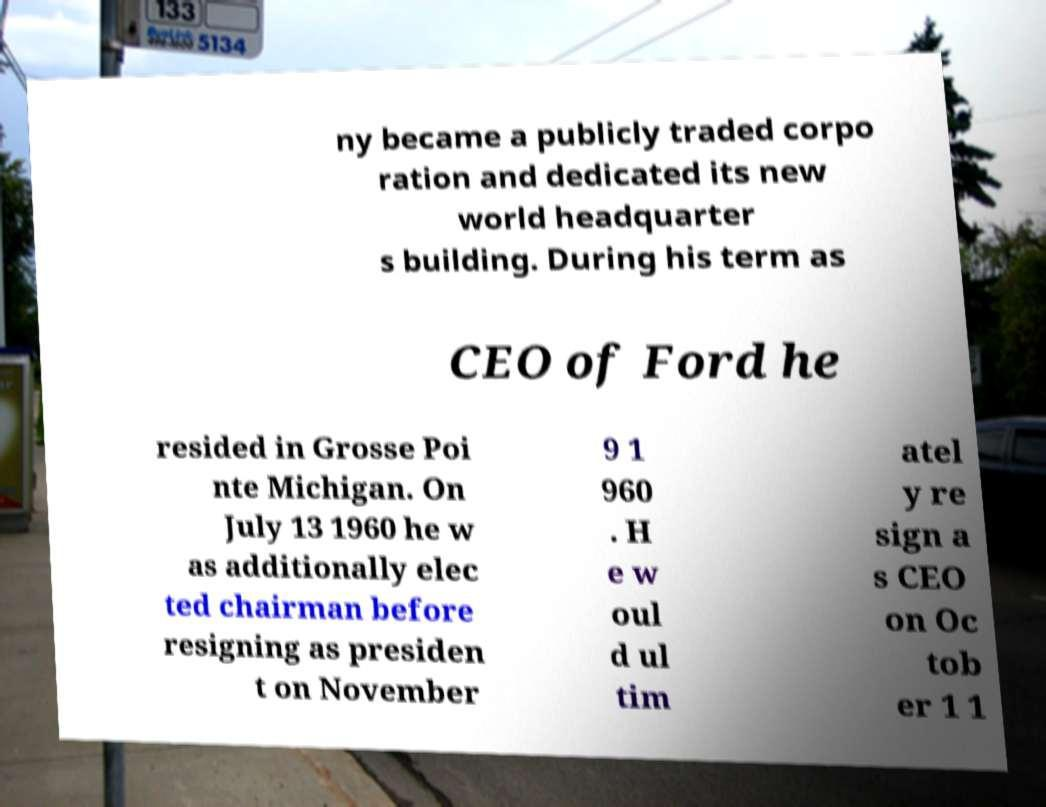I need the written content from this picture converted into text. Can you do that? ny became a publicly traded corpo ration and dedicated its new world headquarter s building. During his term as CEO of Ford he resided in Grosse Poi nte Michigan. On July 13 1960 he w as additionally elec ted chairman before resigning as presiden t on November 9 1 960 . H e w oul d ul tim atel y re sign a s CEO on Oc tob er 1 1 